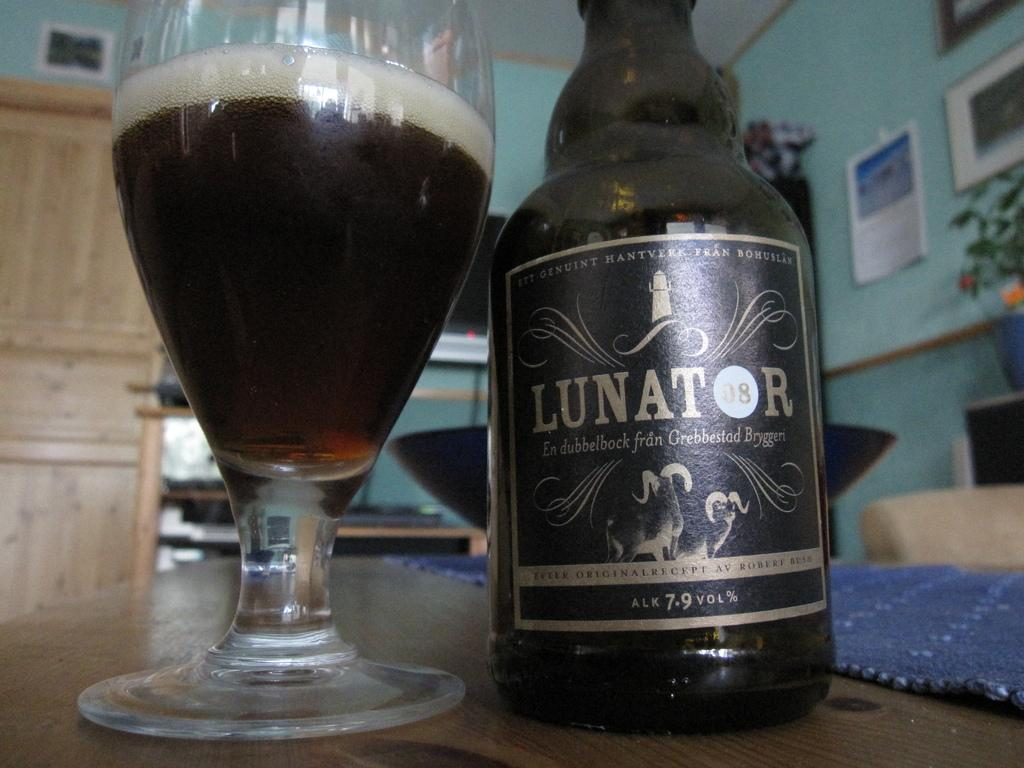<image>
Relay a brief, clear account of the picture shown. Black beer bottle that says Lunator on it next to a cup. 